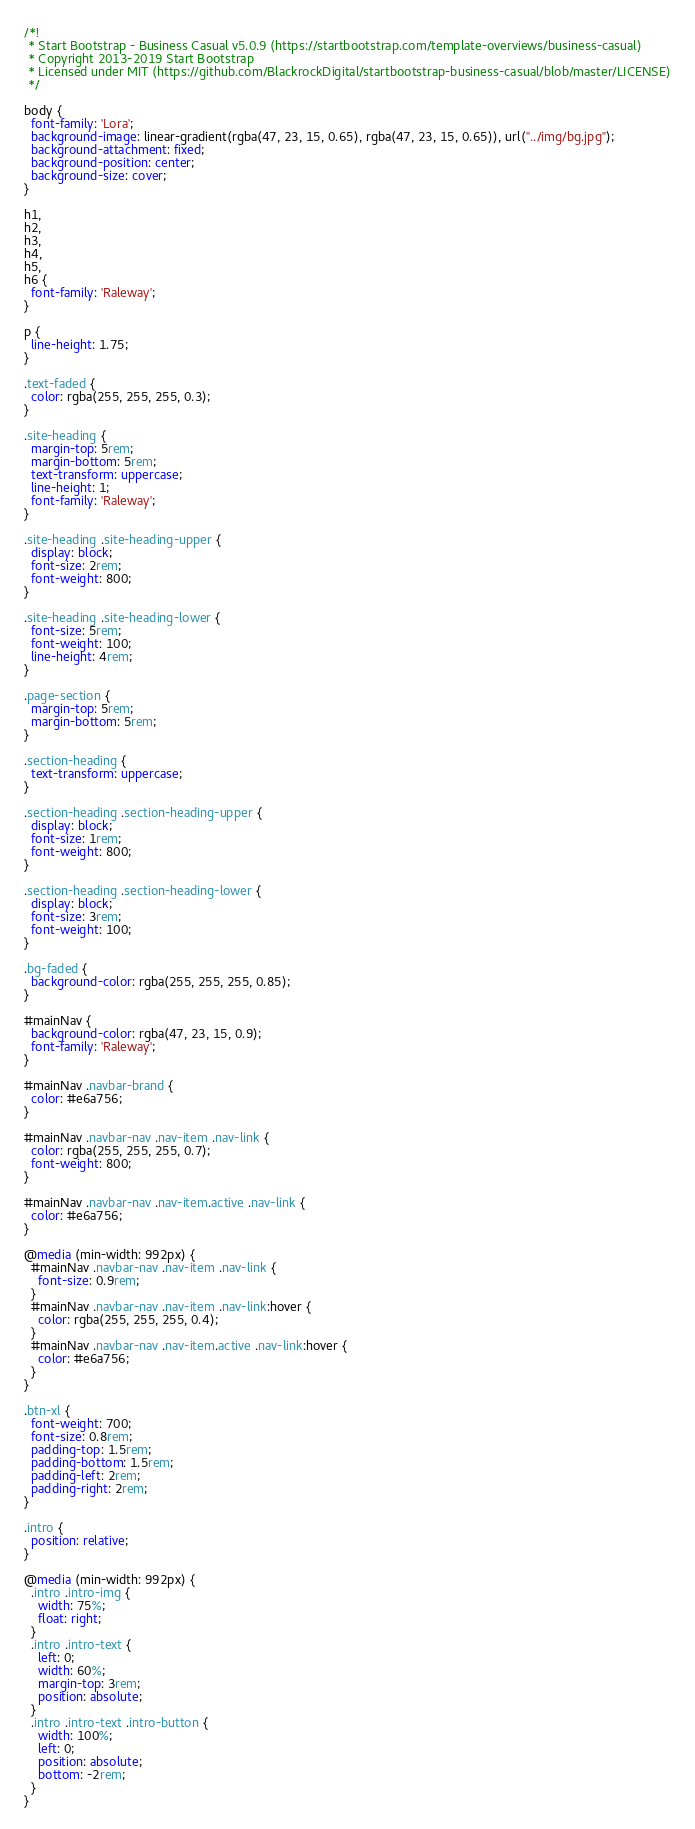<code> <loc_0><loc_0><loc_500><loc_500><_CSS_>/*!
 * Start Bootstrap - Business Casual v5.0.9 (https://startbootstrap.com/template-overviews/business-casual)
 * Copyright 2013-2019 Start Bootstrap
 * Licensed under MIT (https://github.com/BlackrockDigital/startbootstrap-business-casual/blob/master/LICENSE)
 */

body {
  font-family: 'Lora';
  background-image: linear-gradient(rgba(47, 23, 15, 0.65), rgba(47, 23, 15, 0.65)), url("../img/bg.jpg");
  background-attachment: fixed;
  background-position: center;
  background-size: cover;
}

h1,
h2,
h3,
h4,
h5,
h6 {
  font-family: 'Raleway';
}

p {
  line-height: 1.75;
}

.text-faded {
  color: rgba(255, 255, 255, 0.3);
}

.site-heading {
  margin-top: 5rem;
  margin-bottom: 5rem;
  text-transform: uppercase;
  line-height: 1;
  font-family: 'Raleway';
}

.site-heading .site-heading-upper {
  display: block;
  font-size: 2rem;
  font-weight: 800;
}

.site-heading .site-heading-lower {
  font-size: 5rem;
  font-weight: 100;
  line-height: 4rem;
}

.page-section {
  margin-top: 5rem;
  margin-bottom: 5rem;
}

.section-heading {
  text-transform: uppercase;
}

.section-heading .section-heading-upper {
  display: block;
  font-size: 1rem;
  font-weight: 800;
}

.section-heading .section-heading-lower {
  display: block;
  font-size: 3rem;
  font-weight: 100;
}

.bg-faded {
  background-color: rgba(255, 255, 255, 0.85);
}

#mainNav {
  background-color: rgba(47, 23, 15, 0.9);
  font-family: 'Raleway';
}

#mainNav .navbar-brand {
  color: #e6a756;
}

#mainNav .navbar-nav .nav-item .nav-link {
  color: rgba(255, 255, 255, 0.7);
  font-weight: 800;
}

#mainNav .navbar-nav .nav-item.active .nav-link {
  color: #e6a756;
}

@media (min-width: 992px) {
  #mainNav .navbar-nav .nav-item .nav-link {
    font-size: 0.9rem;
  }
  #mainNav .navbar-nav .nav-item .nav-link:hover {
    color: rgba(255, 255, 255, 0.4);
  }
  #mainNav .navbar-nav .nav-item.active .nav-link:hover {
    color: #e6a756;
  }
}

.btn-xl {
  font-weight: 700;
  font-size: 0.8rem;
  padding-top: 1.5rem;
  padding-bottom: 1.5rem;
  padding-left: 2rem;
  padding-right: 2rem;
}

.intro {
  position: relative;
}

@media (min-width: 992px) {
  .intro .intro-img {
    width: 75%;
    float: right;
  }
  .intro .intro-text {
    left: 0;
    width: 60%;
    margin-top: 3rem;
    position: absolute;
  }
  .intro .intro-text .intro-button {
    width: 100%;
    left: 0;
    position: absolute;
    bottom: -2rem;
  }
}
</code> 